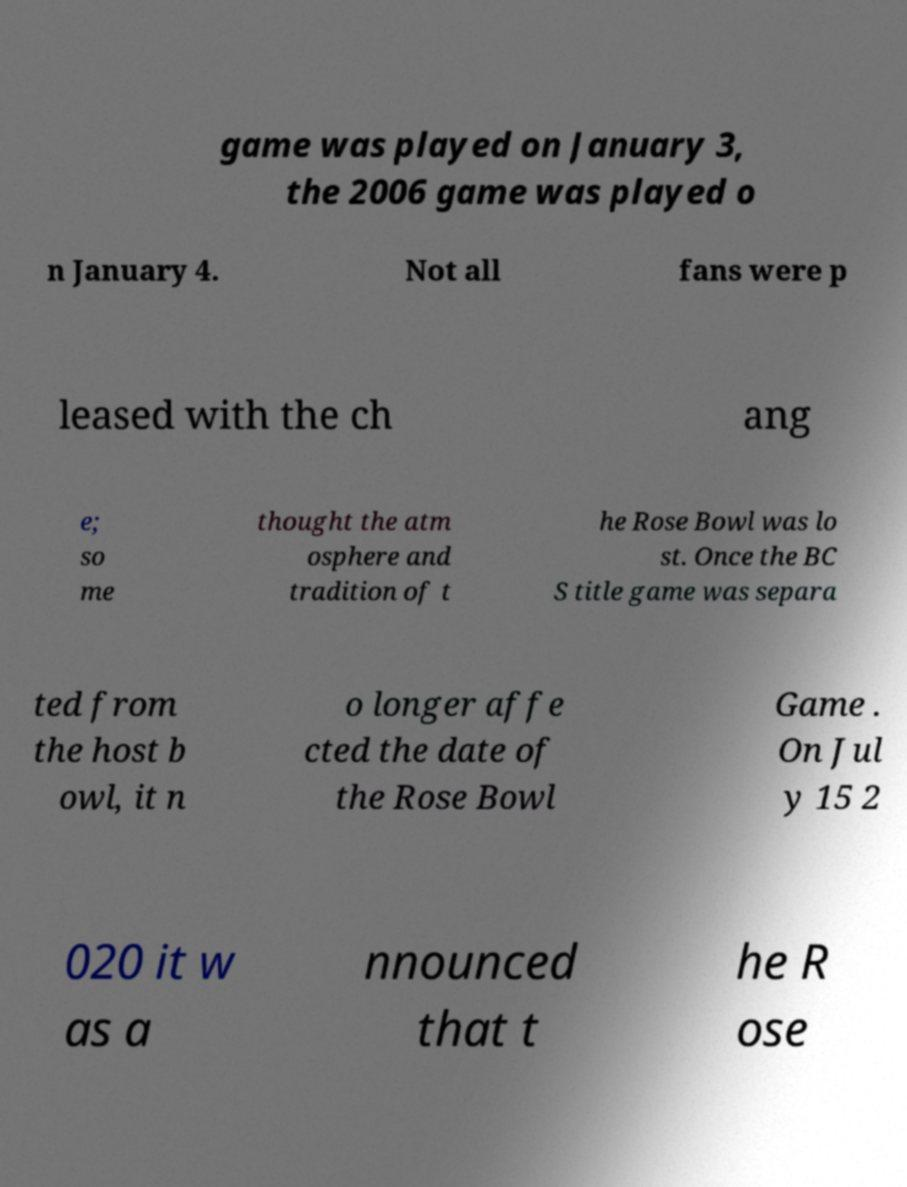Please identify and transcribe the text found in this image. game was played on January 3, the 2006 game was played o n January 4. Not all fans were p leased with the ch ang e; so me thought the atm osphere and tradition of t he Rose Bowl was lo st. Once the BC S title game was separa ted from the host b owl, it n o longer affe cted the date of the Rose Bowl Game . On Jul y 15 2 020 it w as a nnounced that t he R ose 